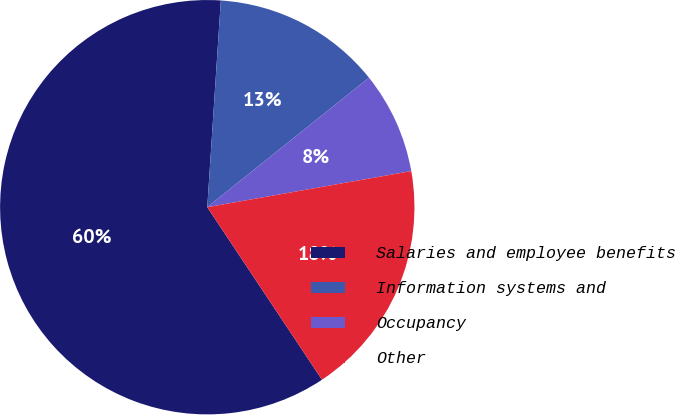Convert chart to OTSL. <chart><loc_0><loc_0><loc_500><loc_500><pie_chart><fcel>Salaries and employee benefits<fcel>Information systems and<fcel>Occupancy<fcel>Other<nl><fcel>60.38%<fcel>13.21%<fcel>7.96%<fcel>18.45%<nl></chart> 